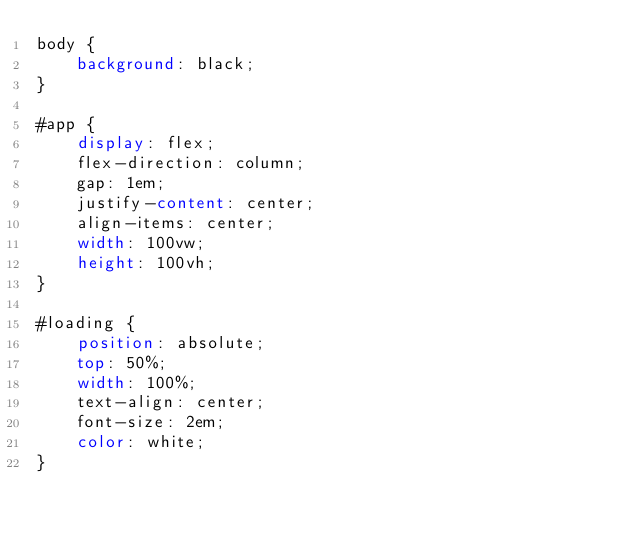Convert code to text. <code><loc_0><loc_0><loc_500><loc_500><_CSS_>body {
    background: black;
}

#app {
    display: flex;
    flex-direction: column;
    gap: 1em;
    justify-content: center;
    align-items: center;
    width: 100vw;
    height: 100vh;
}

#loading {
    position: absolute;
    top: 50%;
    width: 100%;
    text-align: center;
    font-size: 2em;
    color: white;
}
</code> 